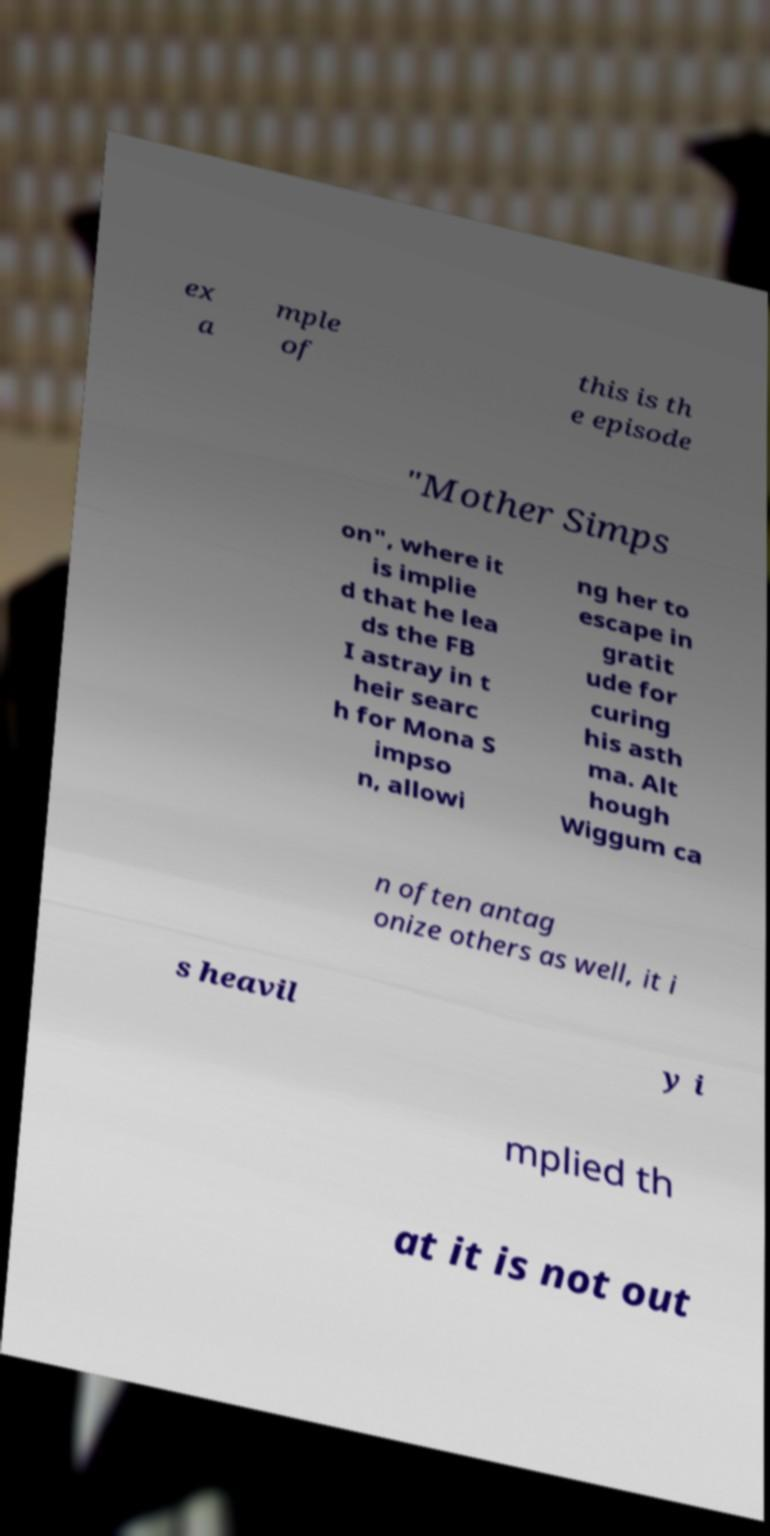Could you assist in decoding the text presented in this image and type it out clearly? ex a mple of this is th e episode "Mother Simps on", where it is implie d that he lea ds the FB I astray in t heir searc h for Mona S impso n, allowi ng her to escape in gratit ude for curing his asth ma. Alt hough Wiggum ca n often antag onize others as well, it i s heavil y i mplied th at it is not out 